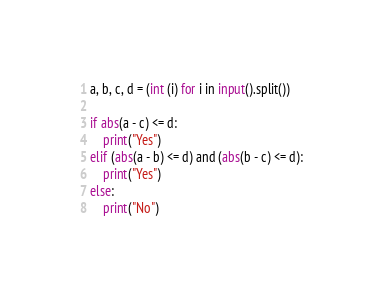<code> <loc_0><loc_0><loc_500><loc_500><_Python_>a, b, c, d = (int (i) for i in input().split())

if abs(a - c) <= d:
    print("Yes")
elif (abs(a - b) <= d) and (abs(b - c) <= d):
    print("Yes")
else:
    print("No")</code> 